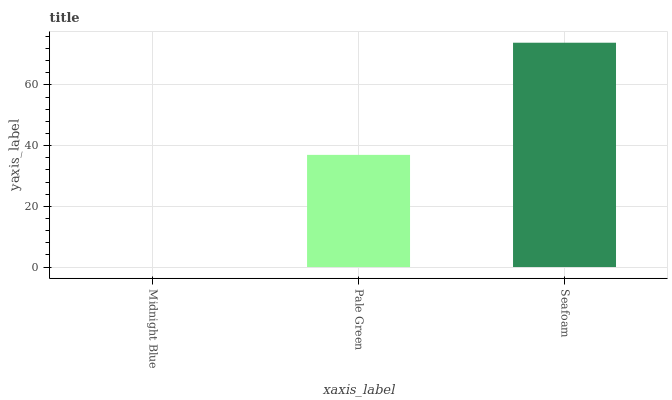Is Midnight Blue the minimum?
Answer yes or no. Yes. Is Seafoam the maximum?
Answer yes or no. Yes. Is Pale Green the minimum?
Answer yes or no. No. Is Pale Green the maximum?
Answer yes or no. No. Is Pale Green greater than Midnight Blue?
Answer yes or no. Yes. Is Midnight Blue less than Pale Green?
Answer yes or no. Yes. Is Midnight Blue greater than Pale Green?
Answer yes or no. No. Is Pale Green less than Midnight Blue?
Answer yes or no. No. Is Pale Green the high median?
Answer yes or no. Yes. Is Pale Green the low median?
Answer yes or no. Yes. Is Seafoam the high median?
Answer yes or no. No. Is Seafoam the low median?
Answer yes or no. No. 